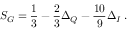Convert formula to latex. <formula><loc_0><loc_0><loc_500><loc_500>S _ { G } = \frac { 1 } { 3 } - \frac { 2 } { 3 } \Delta _ { Q } - \frac { 1 0 } { 9 } \Delta _ { I } \, .</formula> 